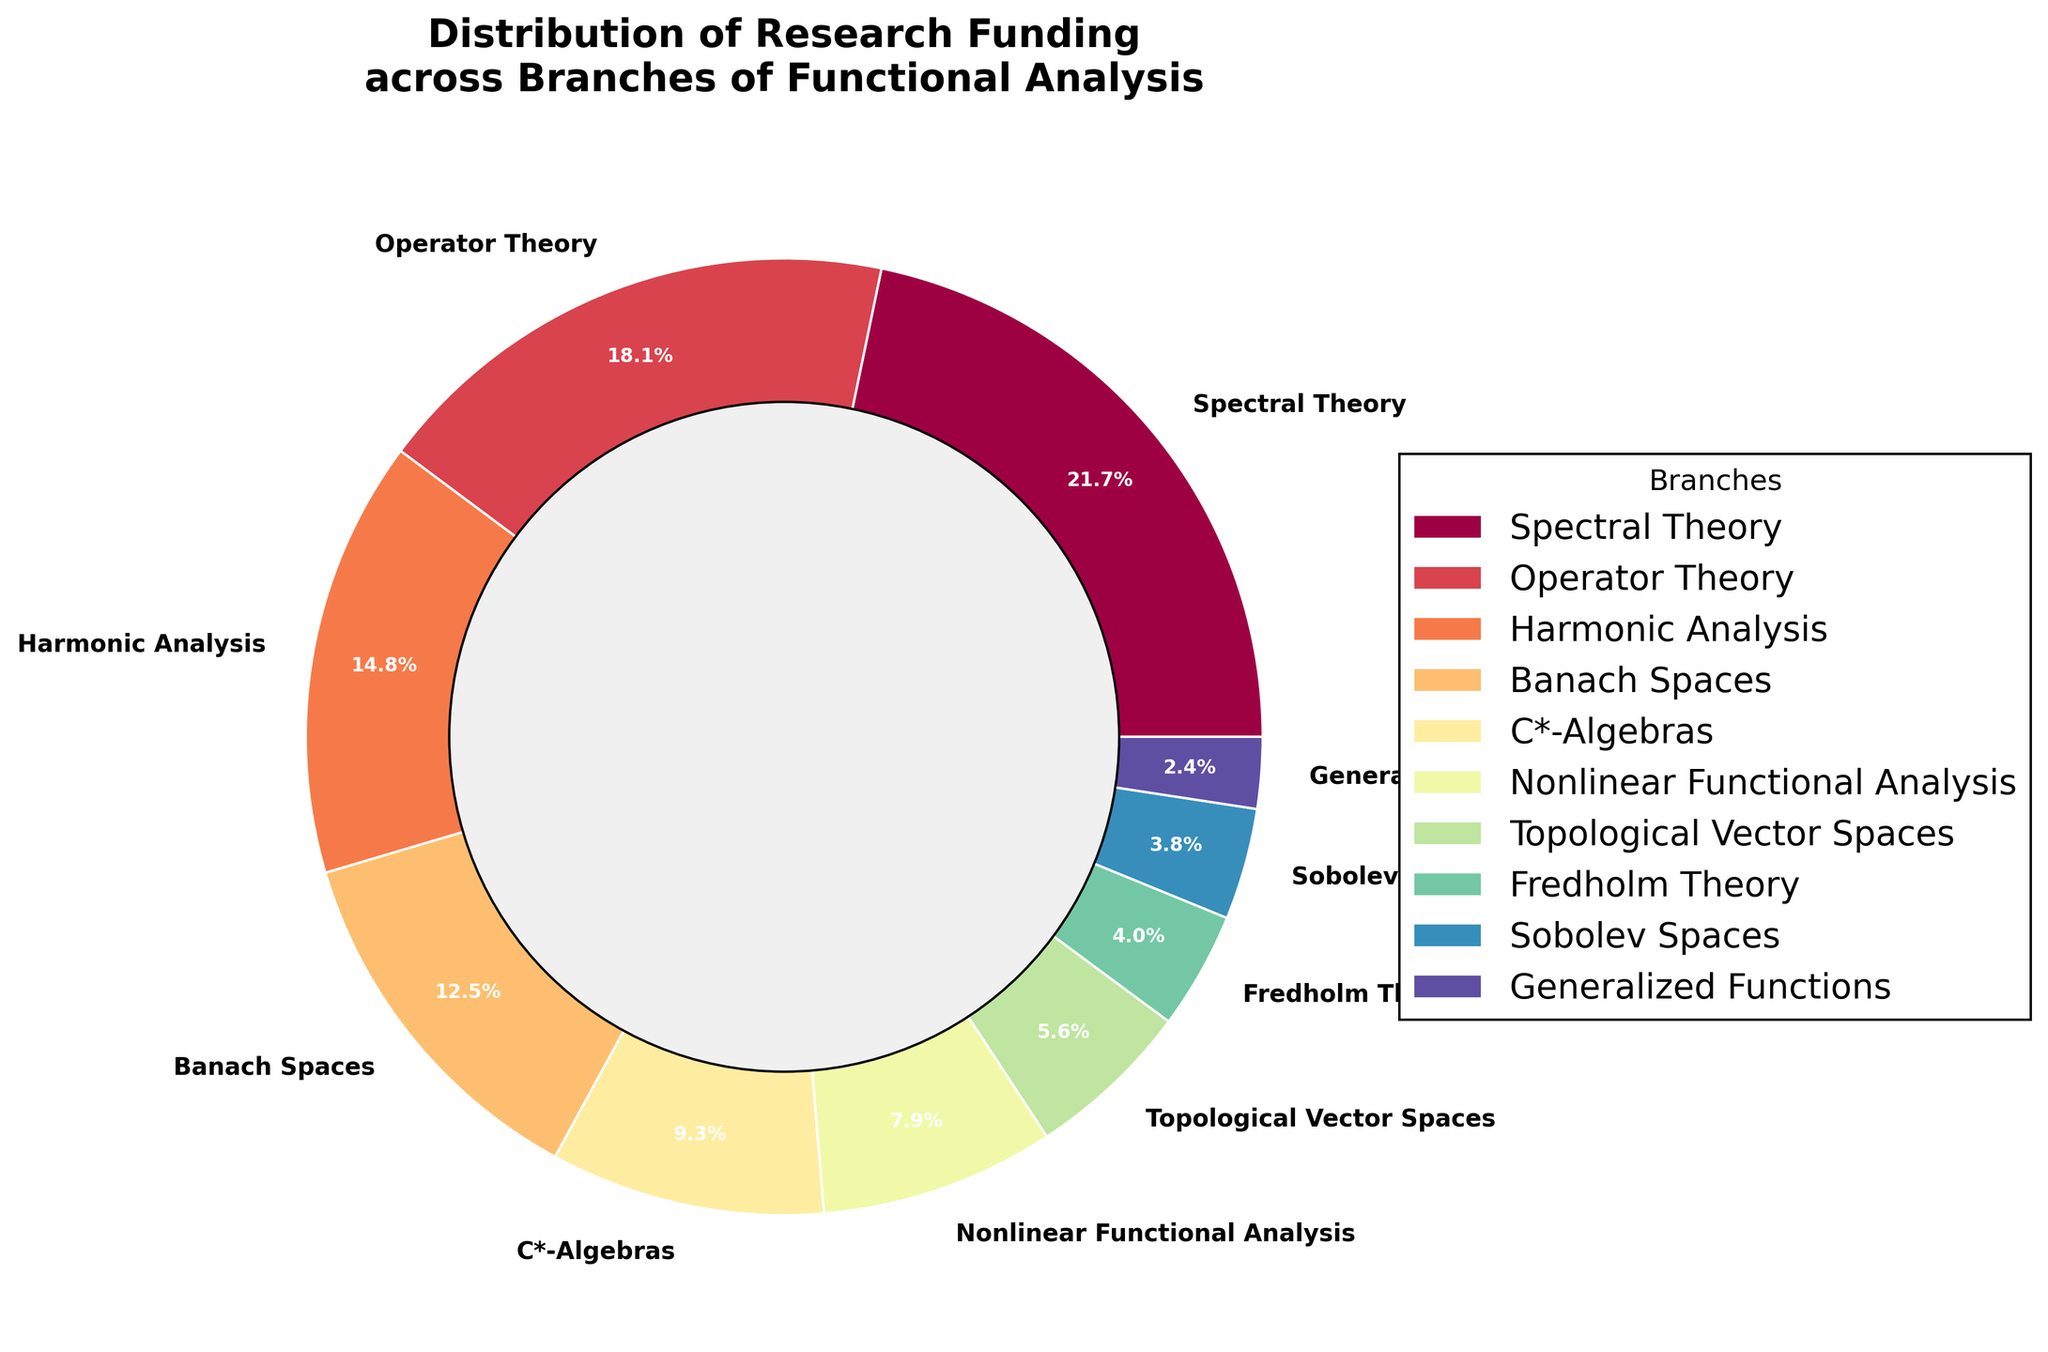Which branch has the highest percentage of research funding? First identify the wedge with the largest value in the pie chart. The largest wedge corresponds to the branch with the highest percentage, which is labeled as "Spectral Theory" with 22.5%.
Answer: Spectral Theory Which branch has the lowest percentage of research funding? Find the smallest wedge in the pie chart. The smallest wedge corresponds to the branch "Generalized Functions" with 2.5%.
Answer: Generalized Functions Which two branches combined receive a funding percentage closest to 30%? Add the percentages of different combinations and find the two branches whose sum is closest to 30%. The closest combination is "Banach Spaces" (12.9%) and "Nonlinear Functional Analysis" (8.2%) with a total of 21.1%. Other combinations either exceed 30% or are farther from it.
Answer: Banach Spaces and Nonlinear Functional Analysis Does Operator Theory receive more funding than Harmonic Analysis? Compare the percentages given for Operator Theory (18.7%) and Harmonic Analysis (15.3%). Since 18.7% is greater than 15.3%, Operator Theory receives more funding.
Answer: Yes What is the combined funding percentage for Sobolev Spaces and Fredholm Theory? Add the percentages of Sobolev Spaces (3.9%) and Fredholm Theory (4.1%). The sum is 3.9% + 4.1% = 8.0%.
Answer: 8.0% Which three branches together receive more than 50% of the total research funding? Identify combinations of branches that together exceed 50%. The three largest branches are "Spectral Theory" (22.5%), "Operator Theory" (18.7%), and "Harmonic Analysis" (15.3%). Adding their percentages: 22.5% + 18.7% + 15.3% = 56.5%, which exceeds 50%.
Answer: Spectral Theory, Operator Theory, and Harmonic Analysis Which branch appears with the darkest color in the chart? In the pie chart, usually, the darkest color is assigned to the first segment. The first segment corresponds to "Spectral Theory".
Answer: Spectral Theory How much more funding does Banach Spaces have compared to C*-Algebras? Subtract the percentage of C*-Algebras (9.6%) from Banach Spaces (12.9%). The difference is 12.9% - 9.6% = 3.3%.
Answer: 3.3% What percentage of research funding goes to branches with less than 10% individually? Sum the percentages of the branches with less than 10%: C*-Algebras (9.6%), Nonlinear Functional Analysis (8.2%), Topological Vector Spaces (5.8%), Fredholm Theory (4.1%), Sobolev Spaces (3.9%), and Generalized Functions (2.5%). The total is 9.6% + 8.2% + 5.8% + 4.1% + 3.9% + 2.5% = 34.1%.
Answer: 34.1% Are any two branches receiving equal funding? Compare the funding percentages of all branches. No two branches have the same funding percentage in the provided data.
Answer: No 